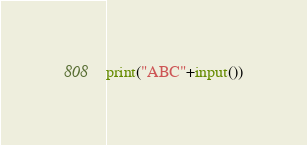<code> <loc_0><loc_0><loc_500><loc_500><_Python_>print("ABC"+input())</code> 